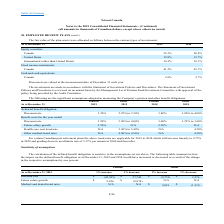According to Loral Space Communications's financial document, When are the plan assets valued each year? December 31 each year. The document states: "Plan assets are valued at the measurement date of December 31 each year...." Also, How often is The Statement of Investment Policies and Procedures reviewed and who reviews it? The document shows two values: annual basis and the Management Level Pension Fund Investment Committee. From the document: "and Procedures is reviewed on an annual basis by the Management Level Pension Fund Investment Committee with approval of the policy being provided by ..." Also, What are the respective percentage of the plan assets fair value allocated to Canada equity securities in 2018 and 2019 respectively? The document shows two values: 20.8% and 22.3%. From the document: "Canada 22.3 % 20.8 % Canada 22.3 % 20.8 %..." Also, can you calculate: What is the percentage change in plan asset fair value allocated in Canada equity securities between 2018 and 2019? Based on the calculation: 22.3% - 20.8% , the result is 1.5 (percentage). This is based on the information: "Canada 22.3 % 20.8 % Canada 22.3 % 20.8 %..." The key data points involved are: 20.8, 22.3. Also, can you calculate: What is the total percentage of plan asset fair value allocated to fixed income instruments in 2018 and 2019? Based on the calculation: 41.2% + 45.7% , the result is 86.9 (percentage). This is based on the information: "Canada 41.2 % 45.7 % Canada 41.2 % 45.7 %..." The key data points involved are: 41.2, 45.7. Also, can you calculate: What is the total percentage of plan asset fair value allocated to cash and cash equivalents in 2018 and 2019? Based on the calculation: 2.6% + 2.7% , the result is 5.3 (percentage). This is based on the information: "United States 19.8 % 12.7 % Canada 2.6 % 2.7 %..." The key data points involved are: 2.6, 2.7. 